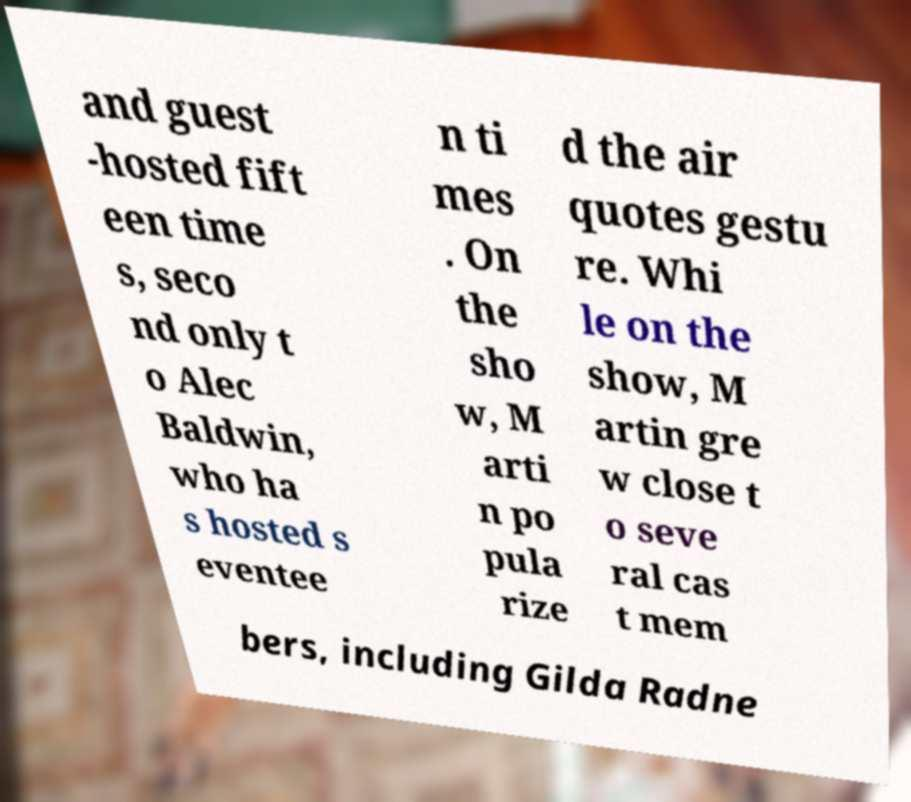For documentation purposes, I need the text within this image transcribed. Could you provide that? and guest -hosted fift een time s, seco nd only t o Alec Baldwin, who ha s hosted s eventee n ti mes . On the sho w, M arti n po pula rize d the air quotes gestu re. Whi le on the show, M artin gre w close t o seve ral cas t mem bers, including Gilda Radne 